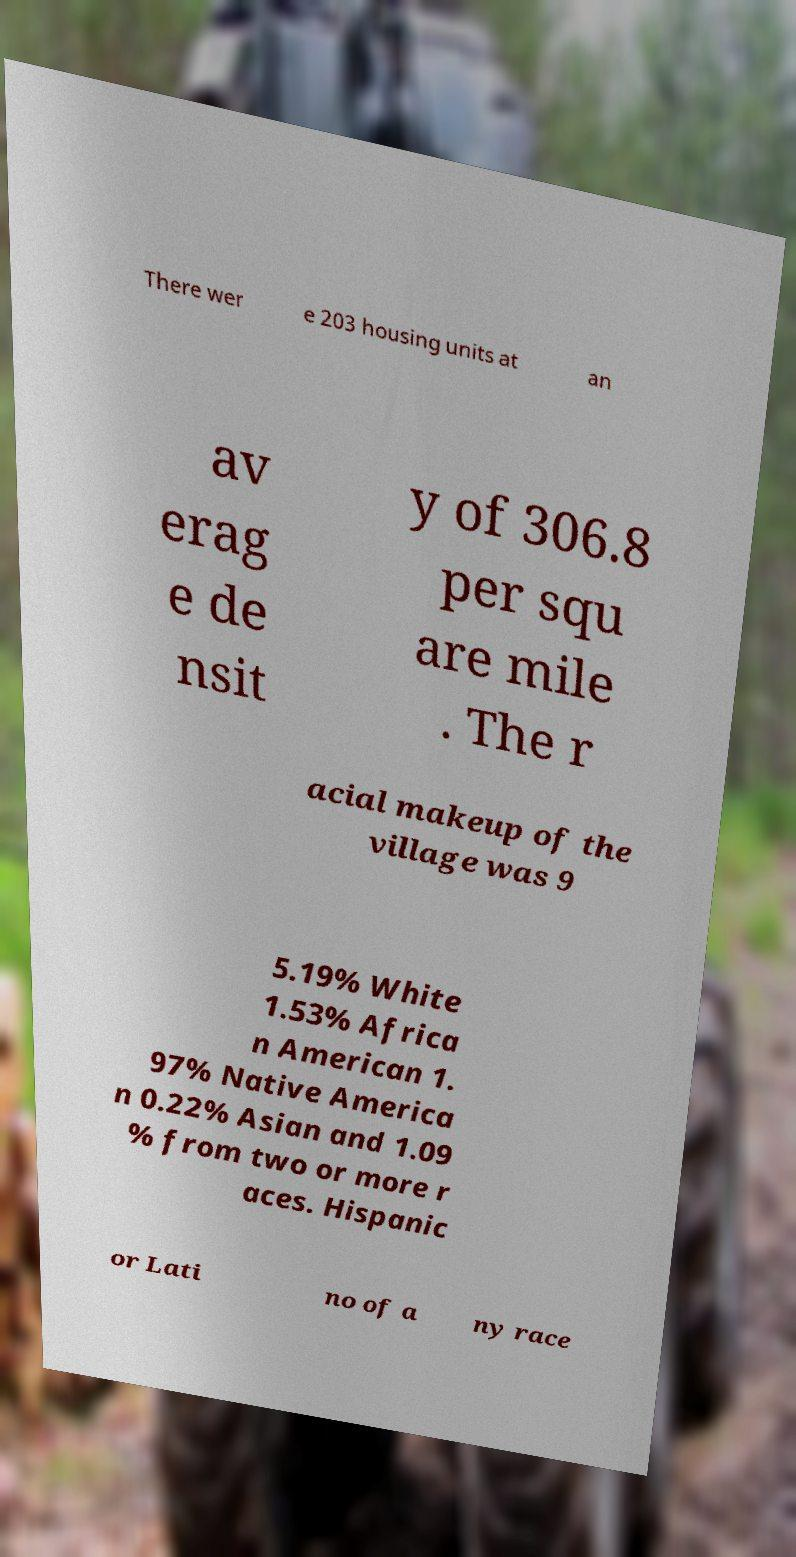Can you read and provide the text displayed in the image?This photo seems to have some interesting text. Can you extract and type it out for me? There wer e 203 housing units at an av erag e de nsit y of 306.8 per squ are mile . The r acial makeup of the village was 9 5.19% White 1.53% Africa n American 1. 97% Native America n 0.22% Asian and 1.09 % from two or more r aces. Hispanic or Lati no of a ny race 